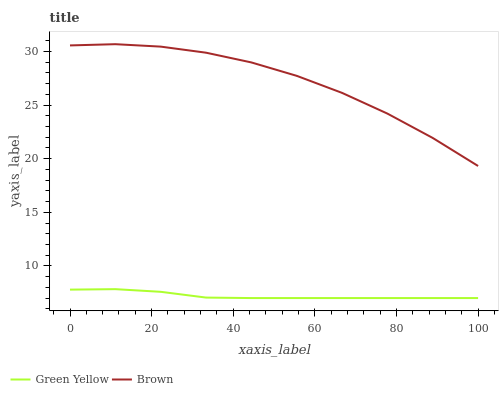Does Green Yellow have the minimum area under the curve?
Answer yes or no. Yes. Does Brown have the maximum area under the curve?
Answer yes or no. Yes. Does Green Yellow have the maximum area under the curve?
Answer yes or no. No. Is Green Yellow the smoothest?
Answer yes or no. Yes. Is Brown the roughest?
Answer yes or no. Yes. Is Green Yellow the roughest?
Answer yes or no. No. Does Green Yellow have the lowest value?
Answer yes or no. Yes. Does Brown have the highest value?
Answer yes or no. Yes. Does Green Yellow have the highest value?
Answer yes or no. No. Is Green Yellow less than Brown?
Answer yes or no. Yes. Is Brown greater than Green Yellow?
Answer yes or no. Yes. Does Green Yellow intersect Brown?
Answer yes or no. No. 